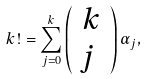Convert formula to latex. <formula><loc_0><loc_0><loc_500><loc_500>k ! = \sum _ { j = 0 } ^ { k } \left ( \begin{array} { c } k \\ j \ \end{array} \right ) \alpha _ { j } ,</formula> 